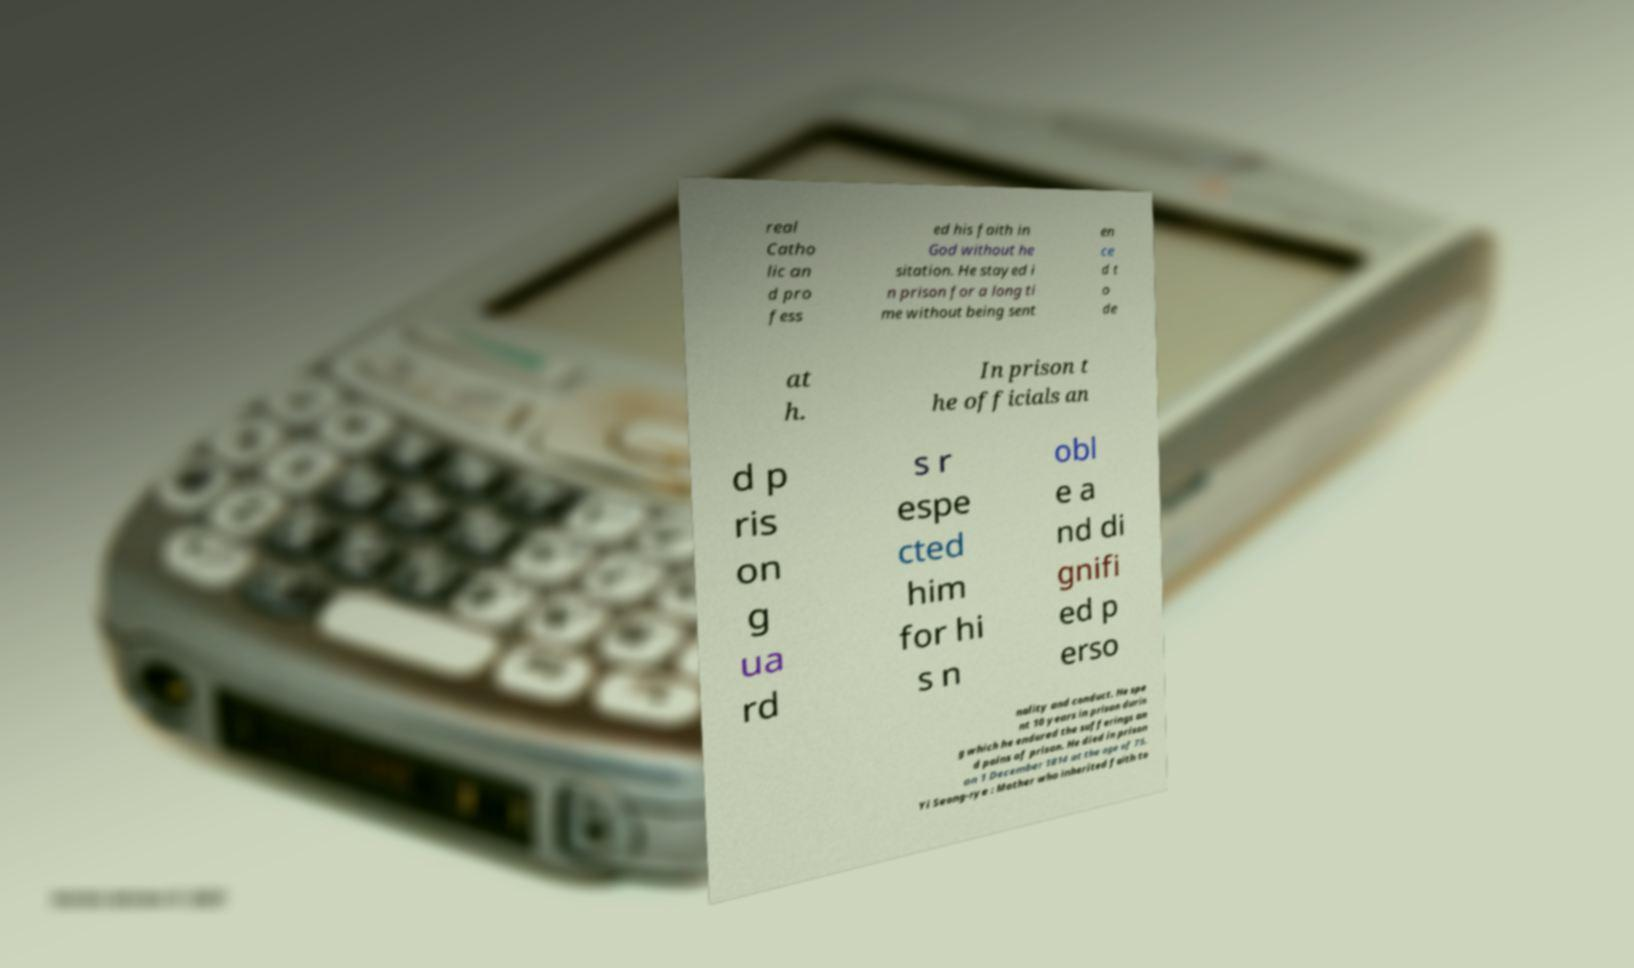Please read and relay the text visible in this image. What does it say? real Catho lic an d pro fess ed his faith in God without he sitation. He stayed i n prison for a long ti me without being sent en ce d t o de at h. In prison t he officials an d p ris on g ua rd s r espe cted him for hi s n obl e a nd di gnifi ed p erso nality and conduct. He spe nt 10 years in prison durin g which he endured the sufferings an d pains of prison. He died in prison on 1 December 1814 at the age of 75. Yi Seong-rye : Mother who inherited faith to 